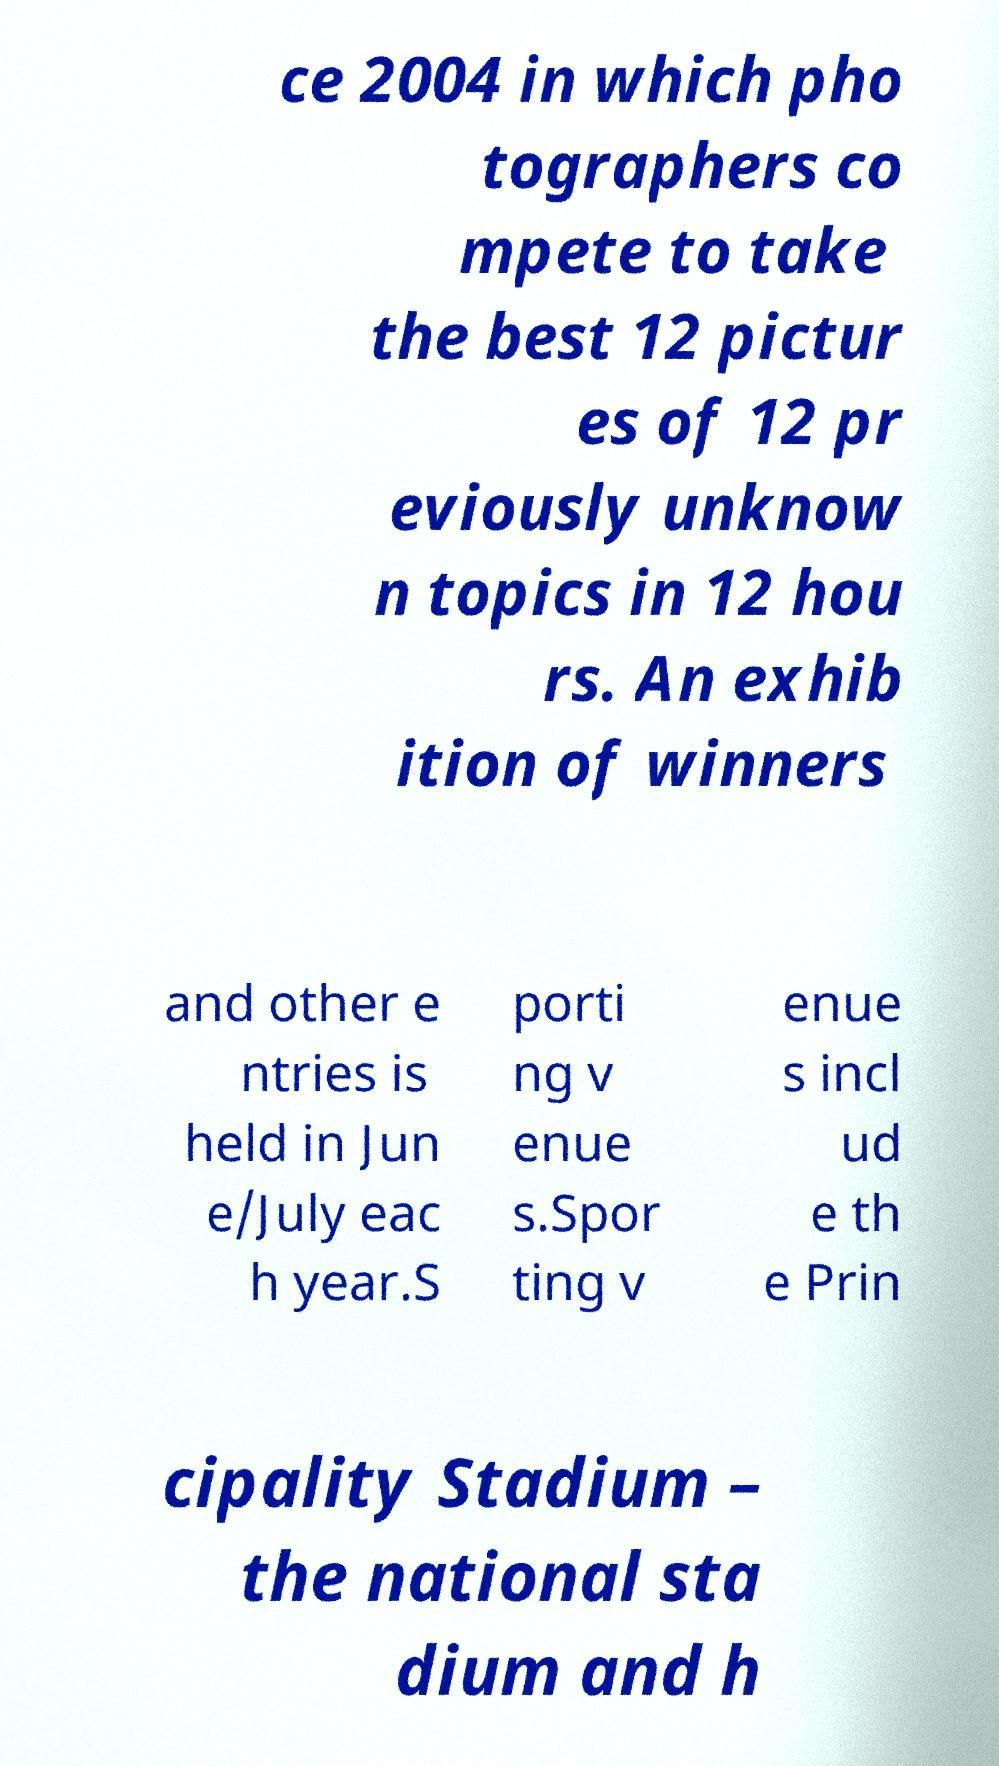There's text embedded in this image that I need extracted. Can you transcribe it verbatim? ce 2004 in which pho tographers co mpete to take the best 12 pictur es of 12 pr eviously unknow n topics in 12 hou rs. An exhib ition of winners and other e ntries is held in Jun e/July eac h year.S porti ng v enue s.Spor ting v enue s incl ud e th e Prin cipality Stadium – the national sta dium and h 